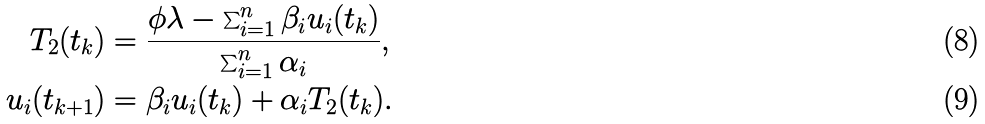Convert formula to latex. <formula><loc_0><loc_0><loc_500><loc_500>T _ { 2 } ( t _ { k } ) & = \frac { \phi \lambda - \sum _ { i = 1 } ^ { n } \beta _ { i } u _ { i } ( t _ { k } ) } { \sum _ { i = 1 } ^ { n } \alpha _ { i } } , \\ u _ { i } ( t _ { k + 1 } ) & = \beta _ { i } u _ { i } ( t _ { k } ) + \alpha _ { i } T _ { 2 } ( t _ { k } ) .</formula> 